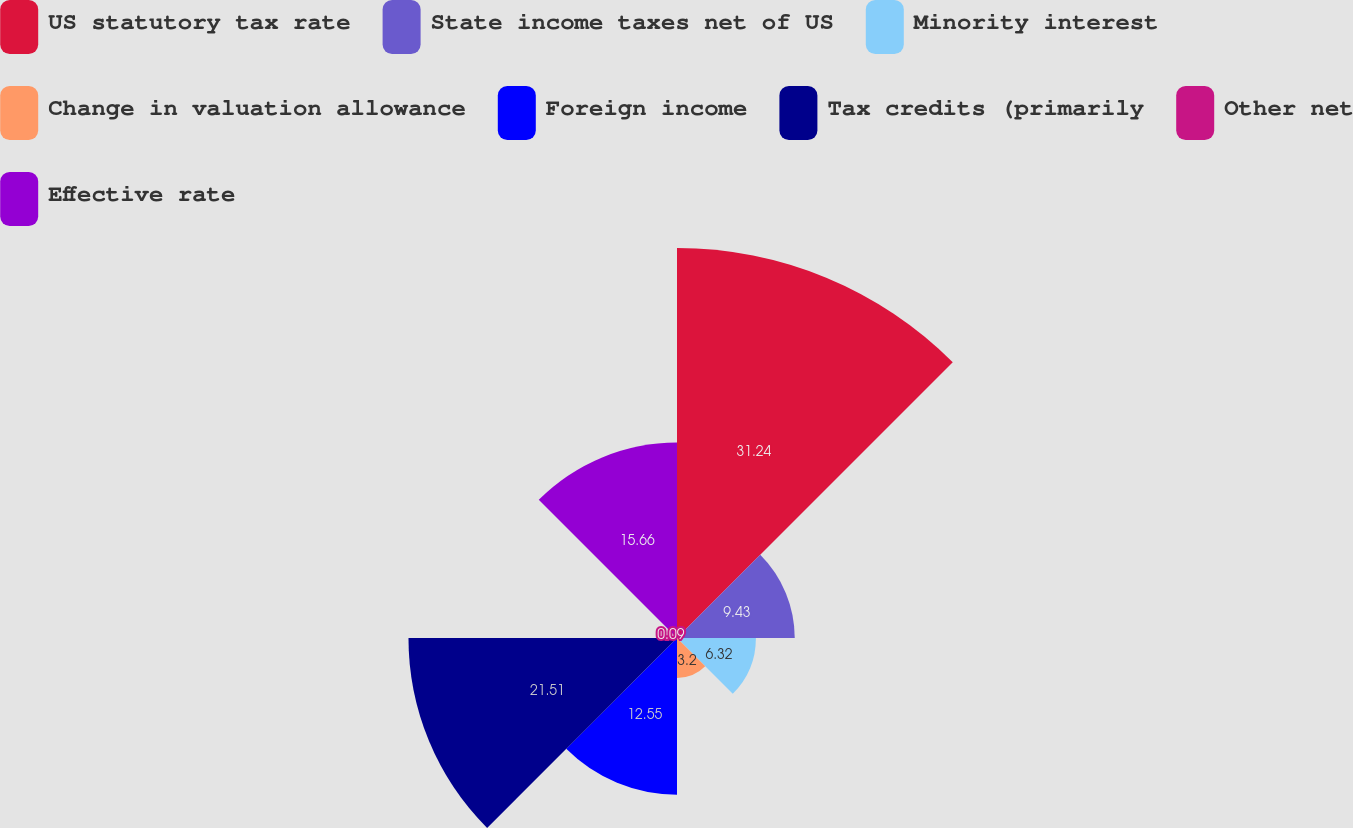Convert chart. <chart><loc_0><loc_0><loc_500><loc_500><pie_chart><fcel>US statutory tax rate<fcel>State income taxes net of US<fcel>Minority interest<fcel>Change in valuation allowance<fcel>Foreign income<fcel>Tax credits (primarily<fcel>Other net<fcel>Effective rate<nl><fcel>31.24%<fcel>9.43%<fcel>6.32%<fcel>3.2%<fcel>12.55%<fcel>21.51%<fcel>0.09%<fcel>15.66%<nl></chart> 